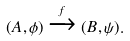<formula> <loc_0><loc_0><loc_500><loc_500>( A , \phi ) \xrightarrow { f } ( B , \psi ) .</formula> 